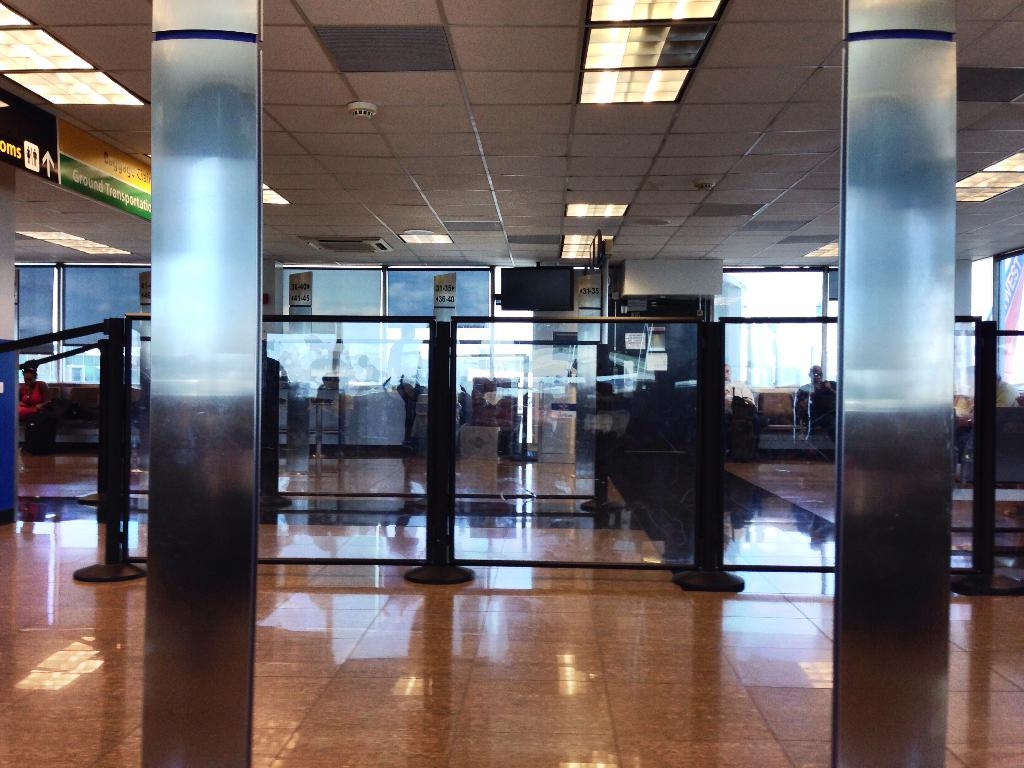What type of location is depicted in the image? The image is an inside view of a house. What architectural features can be seen in the image? There are pillars and rods visible in the image. What material is present in the image? There is glass and lights visible in the image. What type of advertisements are present in the image? There are hoardings in the image. Are there any people present in the image? Yes, there are people in the image. What surface is visible in the image? There is a floor visible in the image. What type of tax is being discussed on the hoardings in the image? There is no discussion of tax on the hoardings in the image; they are advertisements. Can you see any frogs in the image? No, there are no frogs present in the image. 